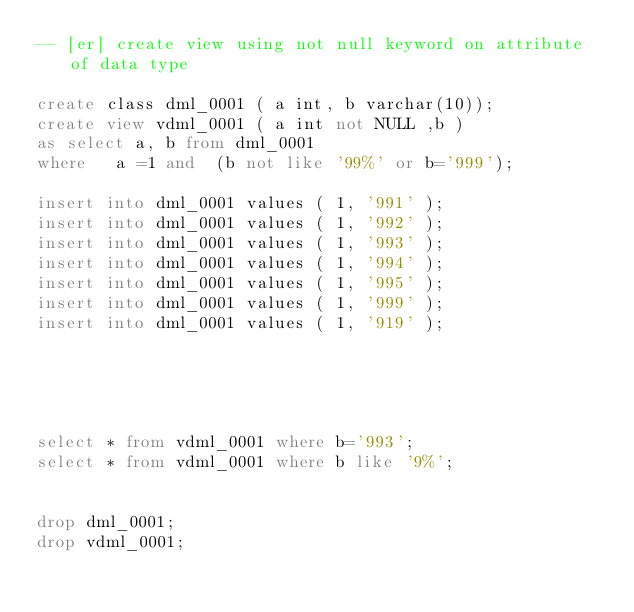Convert code to text. <code><loc_0><loc_0><loc_500><loc_500><_SQL_>-- [er] create view using not null keyword on attribute of data type 

create class dml_0001 ( a int, b varchar(10));
create view vdml_0001 ( a int not NULL ,b )
as select a, b from dml_0001
where   a =1 and  (b not like '99%' or b='999');

insert into dml_0001 values ( 1, '991' );
insert into dml_0001 values ( 1, '992' );
insert into dml_0001 values ( 1, '993' );
insert into dml_0001 values ( 1, '994' );
insert into dml_0001 values ( 1, '995' );
insert into dml_0001 values ( 1, '999' );
insert into dml_0001 values ( 1, '919' );





select * from vdml_0001 where b='993';
select * from vdml_0001 where b like '9%';


drop dml_0001;
drop vdml_0001;</code> 